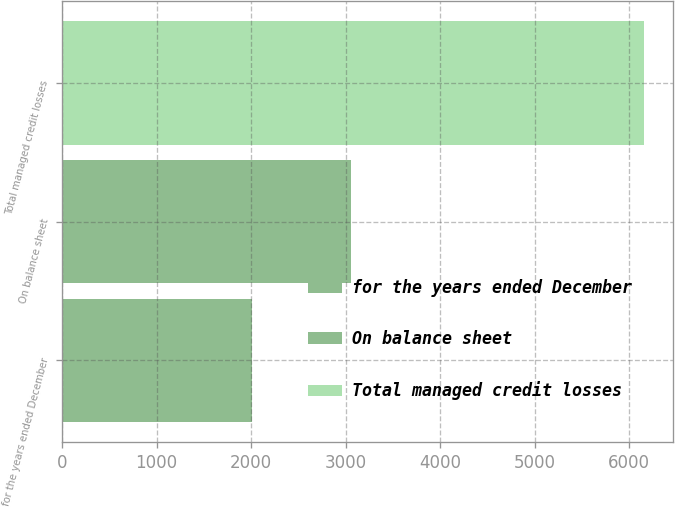Convert chart to OTSL. <chart><loc_0><loc_0><loc_500><loc_500><bar_chart><fcel>for the years ended December<fcel>On balance sheet<fcel>Total managed credit losses<nl><fcel>2008<fcel>3052<fcel>6159<nl></chart> 